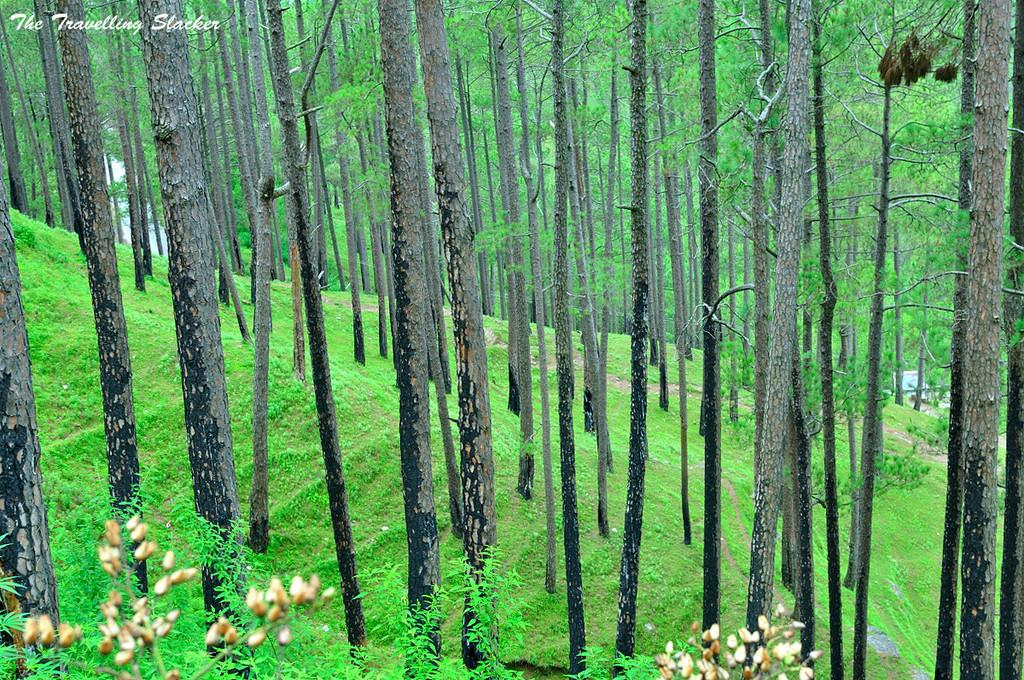What type of flowers can be seen in the image? There are cream-colored flowers in the image. Where are the flowers located? The flowers are on plants. What can be seen in the background of the image? There is grass and many trees visible in the background of the image. Where can the guide to making soda be found in the image? There is no guide to making soda present in the image. What type of shelf is visible in the image? There is no shelf visible in the image. 